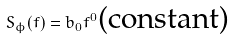Convert formula to latex. <formula><loc_0><loc_0><loc_500><loc_500>S _ { \phi } ( f ) = b _ { 0 } f ^ { 0 } \text {(constant)}</formula> 